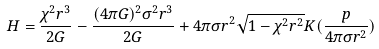Convert formula to latex. <formula><loc_0><loc_0><loc_500><loc_500>H = \frac { \chi ^ { 2 } r ^ { 3 } } { 2 G } - \frac { ( 4 \pi G ) ^ { 2 } \sigma ^ { 2 } r ^ { 3 } } { 2 G } + 4 \pi \sigma r ^ { 2 } \sqrt { 1 - \chi ^ { 2 } r ^ { 2 } } K ( \frac { p } { 4 \pi \sigma r ^ { 2 } } )</formula> 